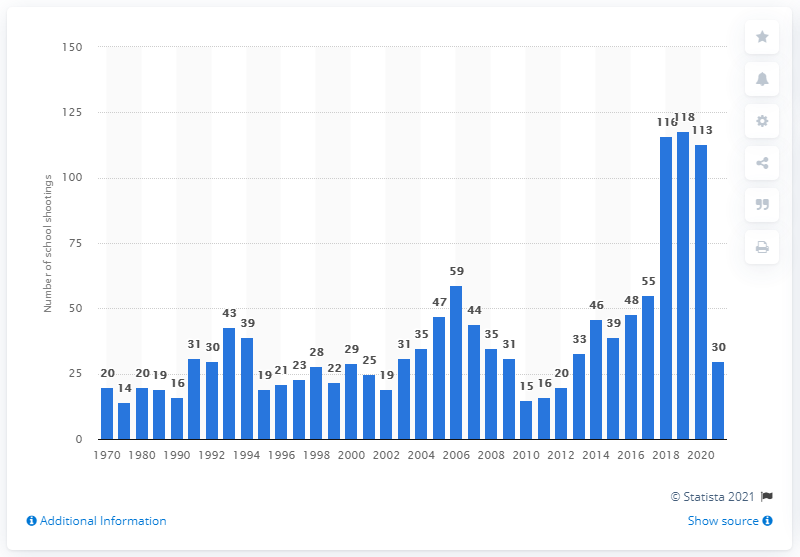Draw attention to some important aspects in this diagram. There were 118 school shootings in 2019. As of March 2021, there had been approximately 30 school shootings in the United States. 